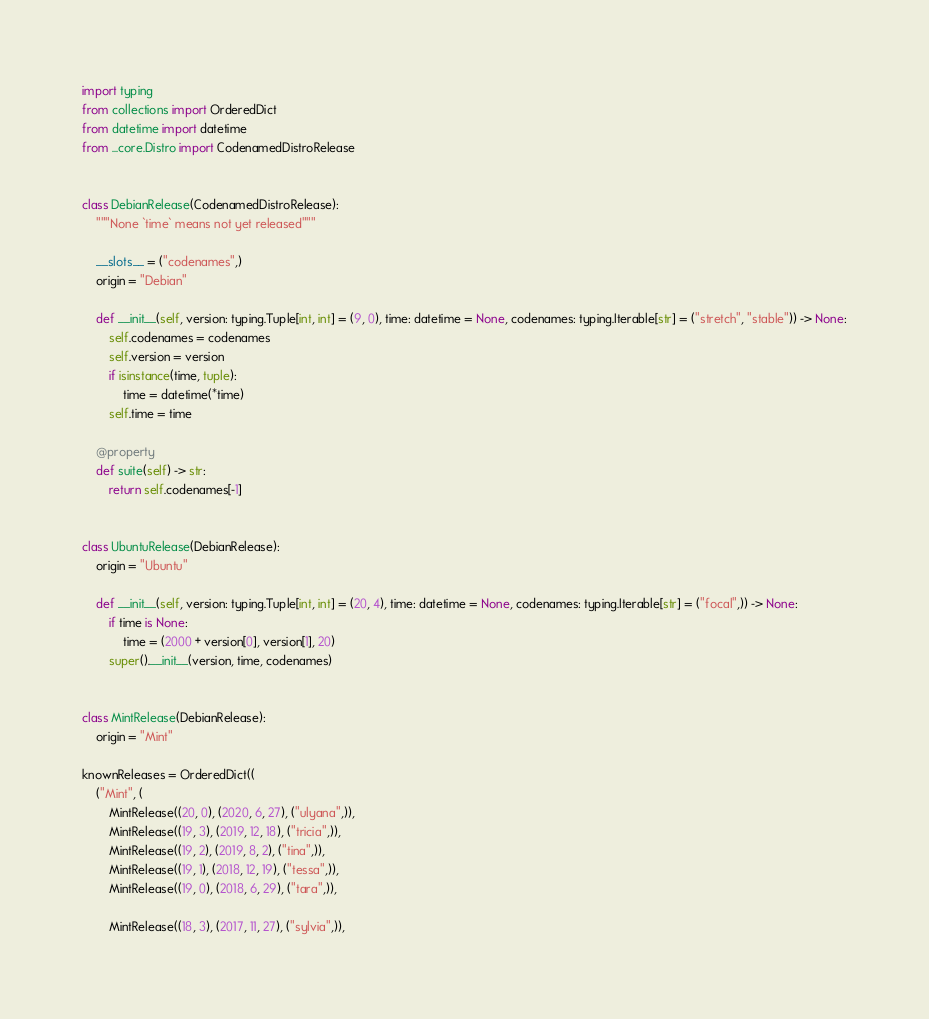Convert code to text. <code><loc_0><loc_0><loc_500><loc_500><_Python_>import typing
from collections import OrderedDict
from datetime import datetime
from ...core.Distro import CodenamedDistroRelease


class DebianRelease(CodenamedDistroRelease):
	"""None `time` means not yet released"""

	__slots__ = ("codenames",)
	origin = "Debian"

	def __init__(self, version: typing.Tuple[int, int] = (9, 0), time: datetime = None, codenames: typing.Iterable[str] = ("stretch", "stable")) -> None:
		self.codenames = codenames
		self.version = version
		if isinstance(time, tuple):
			time = datetime(*time)
		self.time = time

	@property
	def suite(self) -> str:
		return self.codenames[-1]


class UbuntuRelease(DebianRelease):
	origin = "Ubuntu"

	def __init__(self, version: typing.Tuple[int, int] = (20, 4), time: datetime = None, codenames: typing.Iterable[str] = ("focal",)) -> None:
		if time is None:
			time = (2000 + version[0], version[1], 20)
		super().__init__(version, time, codenames)


class MintRelease(DebianRelease):
	origin = "Mint"

knownReleases = OrderedDict((
	("Mint", (
		MintRelease((20, 0), (2020, 6, 27), ("ulyana",)),
		MintRelease((19, 3), (2019, 12, 18), ("tricia",)),
		MintRelease((19, 2), (2019, 8, 2), ("tina",)),
		MintRelease((19, 1), (2018, 12, 19), ("tessa",)),
		MintRelease((19, 0), (2018, 6, 29), ("tara",)),
	
		MintRelease((18, 3), (2017, 11, 27), ("sylvia",)),</code> 